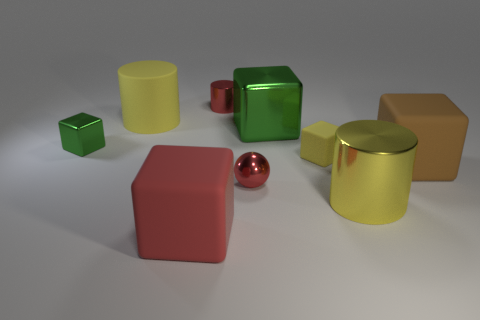How might the lighting in the image affect the perception of the objects? The lighting in the image casts soft shadows and highlights, enhancing the three-dimensional quality of the objects. It creates a warm atmosphere and helps to accentuate the different textures and finishes of the objects. The glossy objects reflect more light and appear brighter, while the matte surfaces absorb light, appearing flatter. The directionality of the light also contributes to the perception of the objects' shapes and the overall depth of the scene. 